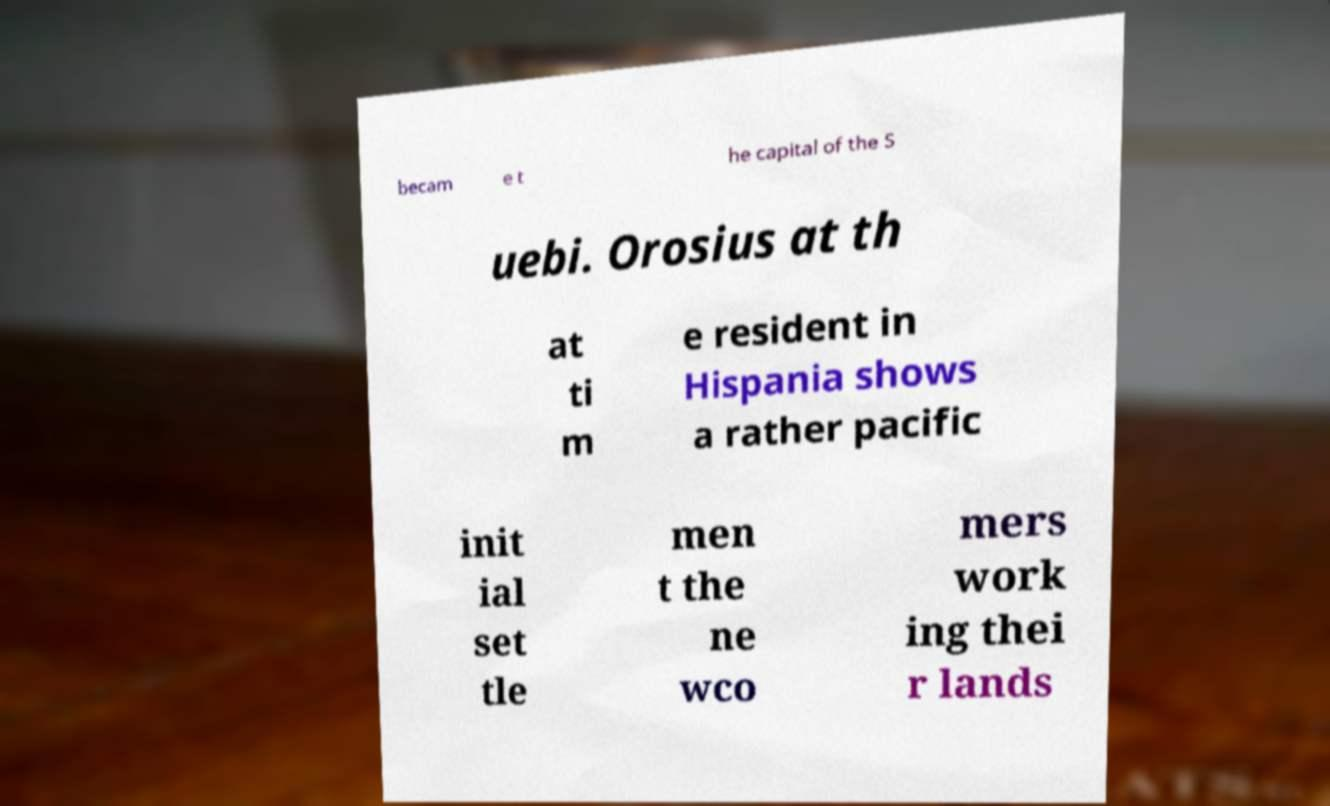There's text embedded in this image that I need extracted. Can you transcribe it verbatim? becam e t he capital of the S uebi. Orosius at th at ti m e resident in Hispania shows a rather pacific init ial set tle men t the ne wco mers work ing thei r lands 